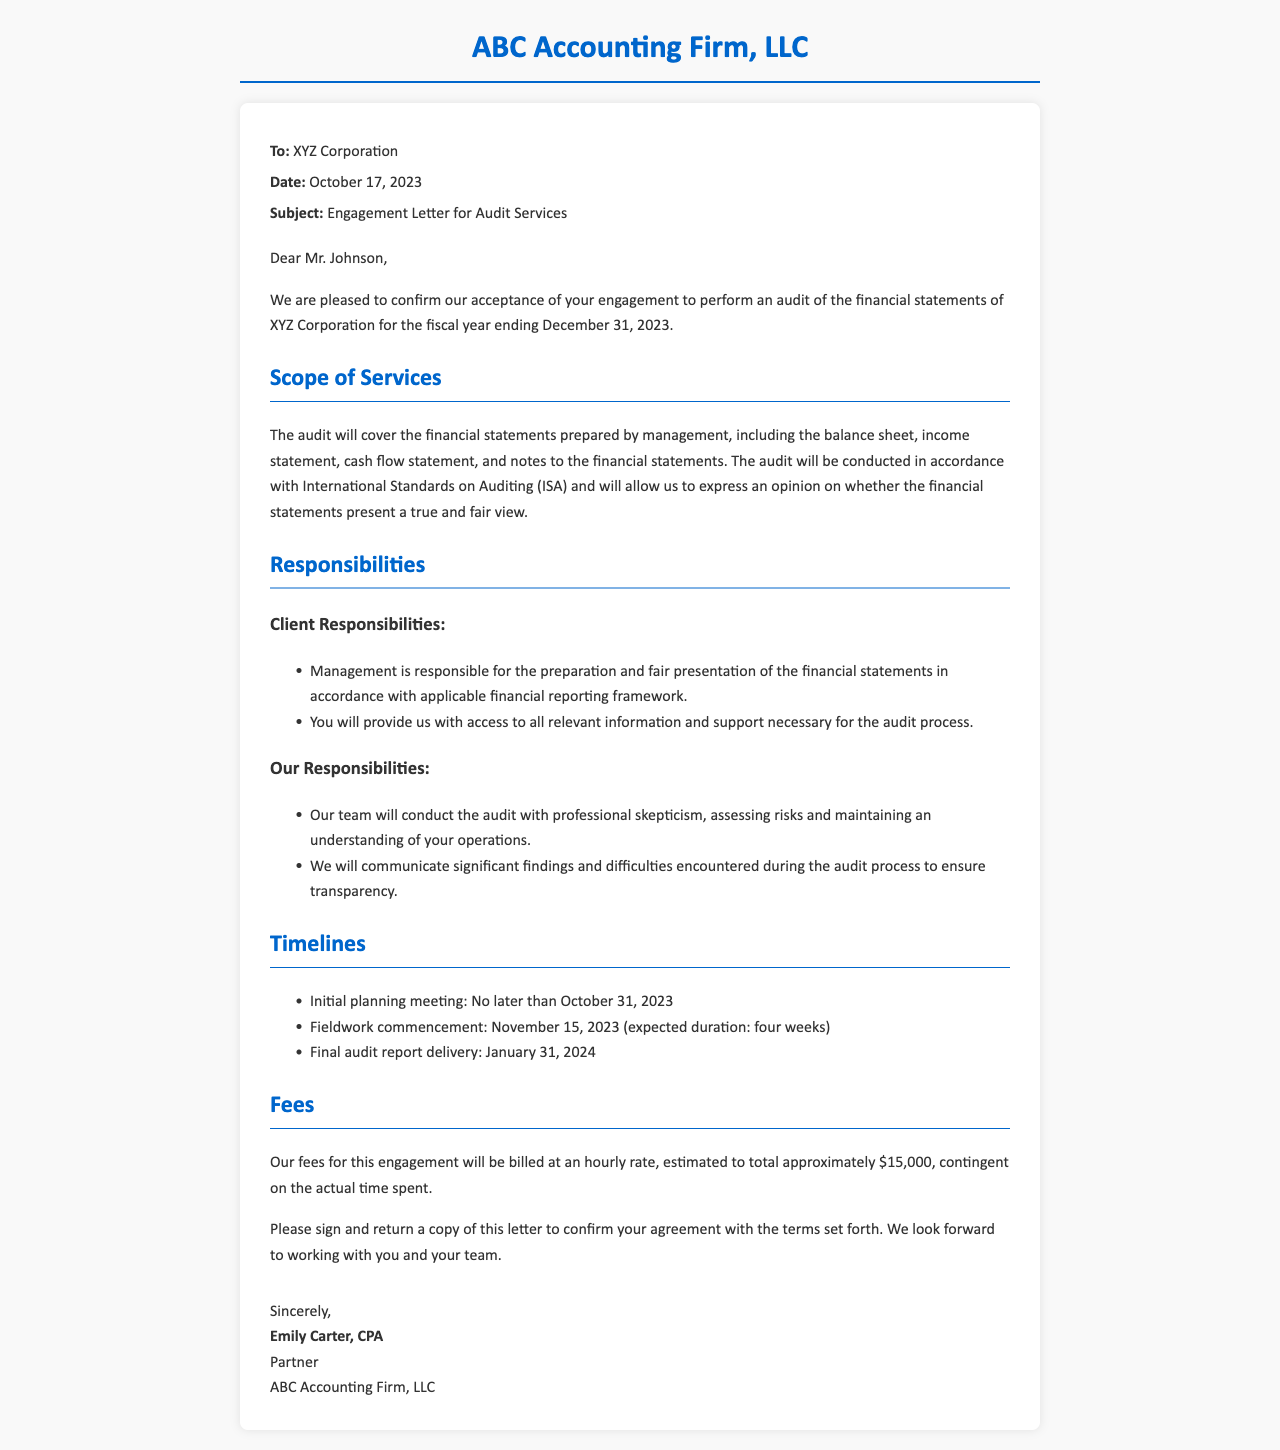What is the name of the accounting firm? The name of the accounting firm is mentioned in the letterhead of the document.
Answer: ABC Accounting Firm, LLC Who is the recipient of the engagement letter? The recipient of the engagement letter is stated at the beginning of the letter.
Answer: XYZ Corporation What is the date of the engagement letter? The date is provided in the header section of the document.
Answer: October 17, 2023 What is the expected duration of the fieldwork? The expected duration for fieldwork is stated in the timelines section.
Answer: four weeks When is the initial planning meeting scheduled? The date for the initial planning meeting is specified in the timelines section.
Answer: October 31, 2023 What is the estimated total fee for the audit engagement? The estimated fee is mentioned in the fees section of the letter.
Answer: $15,000 What is the primary responsibility of management during the audit? Management's key responsibility can be found in the responsibilities section.
Answer: Preparation and fair presentation of the financial statements When will the final audit report be delivered? The delivery date of the final audit report is provided in the timelines section.
Answer: January 31, 2024 Who signed the engagement letter? The signatory details are found in the signature section at the end of the letter.
Answer: Emily Carter, CPA 